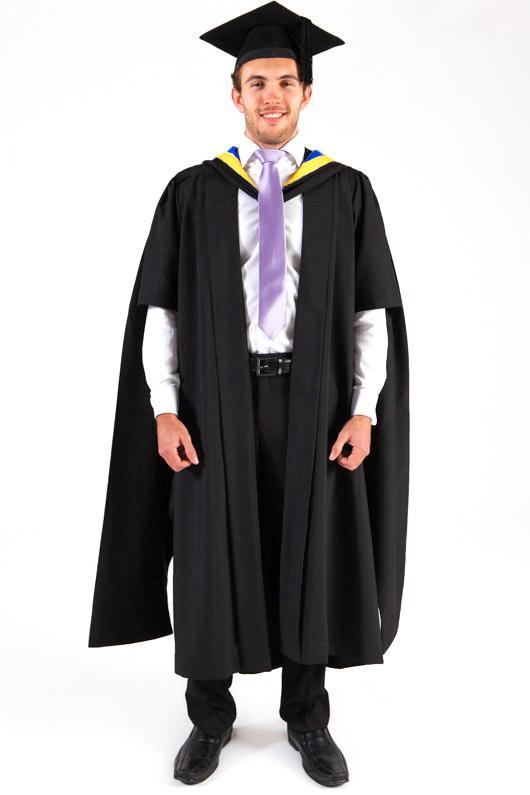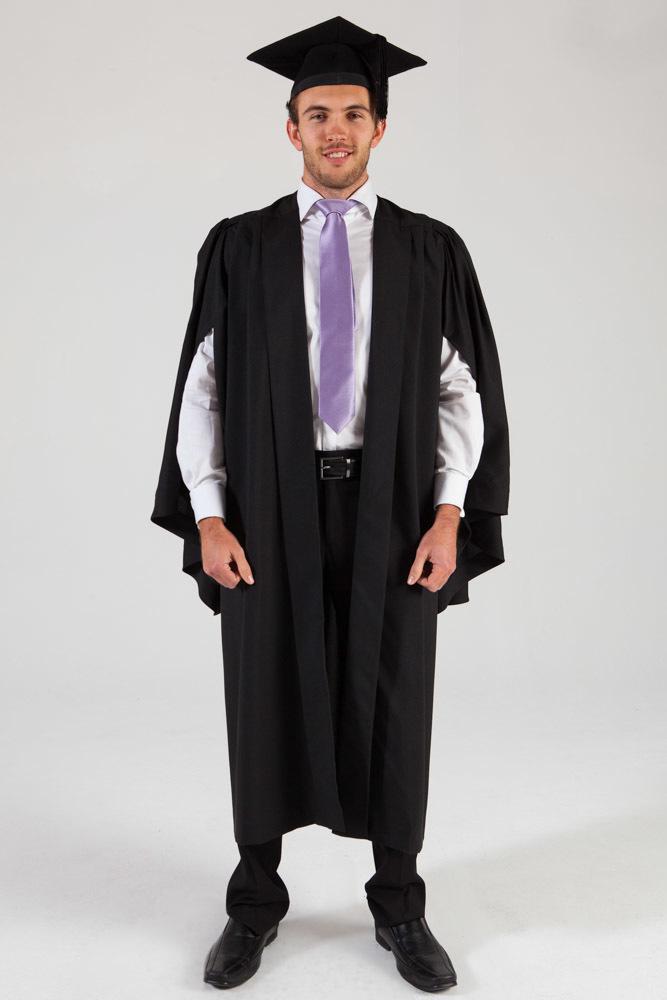The first image is the image on the left, the second image is the image on the right. Considering the images on both sides, is "The graduation attire in the image on the left is being modeled by a female." valid? Answer yes or no. No. The first image is the image on the left, the second image is the image on the right. For the images shown, is this caption "Exactly one camera-facing female and one camera-facing male are shown modeling graduation attire." true? Answer yes or no. No. 